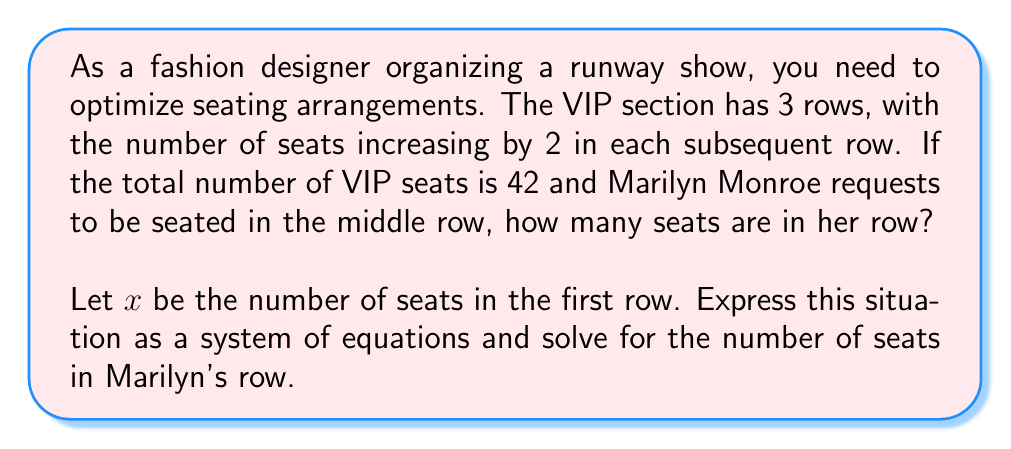What is the answer to this math problem? Let's approach this step-by-step:

1) Let $x$ be the number of seats in the first row. Then:
   - First row: $x$ seats
   - Second row (Marilyn's row): $x + 2$ seats
   - Third row: $x + 4$ seats

2) The total number of seats is 42, so we can write our first equation:
   $$x + (x + 2) + (x + 4) = 42$$

3) Simplify the left side of the equation:
   $$3x + 6 = 42$$

4) Subtract 6 from both sides:
   $$3x = 36$$

5) Divide both sides by 3:
   $$x = 12$$

6) Now that we know $x$, we can calculate the number of seats in Marilyn's row (the second row):
   $$x + 2 = 12 + 2 = 14$$

Therefore, Marilyn's row (the middle row) has 14 seats.
Answer: 14 seats 